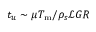Convert formula to latex. <formula><loc_0><loc_0><loc_500><loc_500>t _ { u } \sim \mu T _ { m } / \rho _ { s } \mathcal { L } G R</formula> 